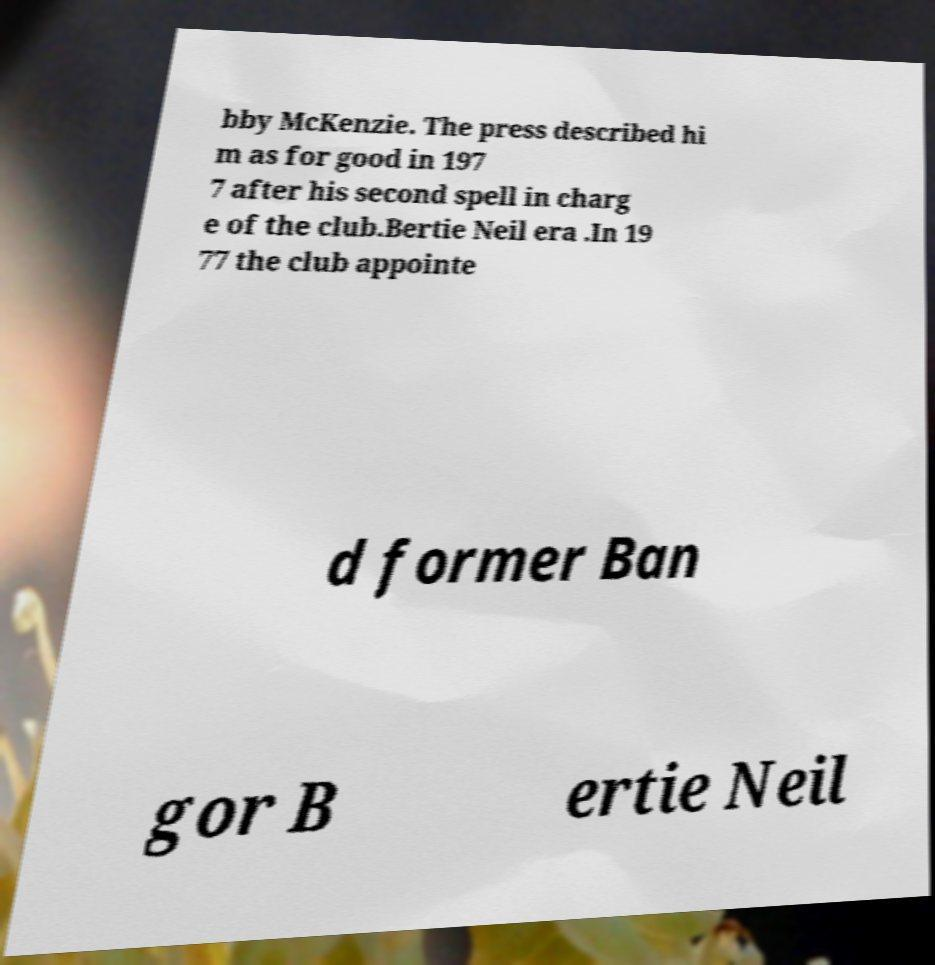Please identify and transcribe the text found in this image. bby McKenzie. The press described hi m as for good in 197 7 after his second spell in charg e of the club.Bertie Neil era .In 19 77 the club appointe d former Ban gor B ertie Neil 